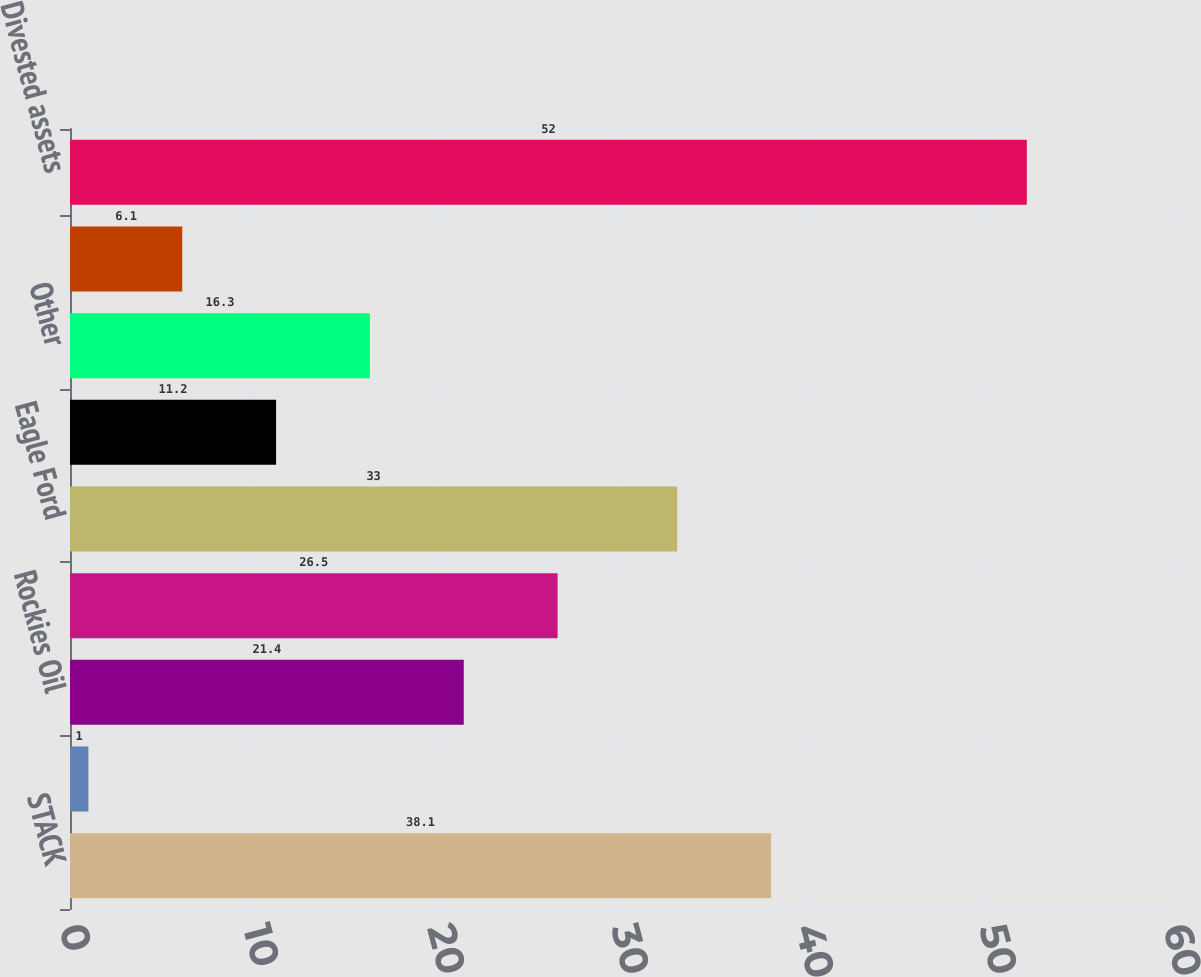<chart> <loc_0><loc_0><loc_500><loc_500><bar_chart><fcel>STACK<fcel>Delaware Basin<fcel>Rockies Oil<fcel>Heavy Oil<fcel>Eagle Ford<fcel>Barnett Shale<fcel>Other<fcel>Retained assets<fcel>Divested assets<nl><fcel>38.1<fcel>1<fcel>21.4<fcel>26.5<fcel>33<fcel>11.2<fcel>16.3<fcel>6.1<fcel>52<nl></chart> 